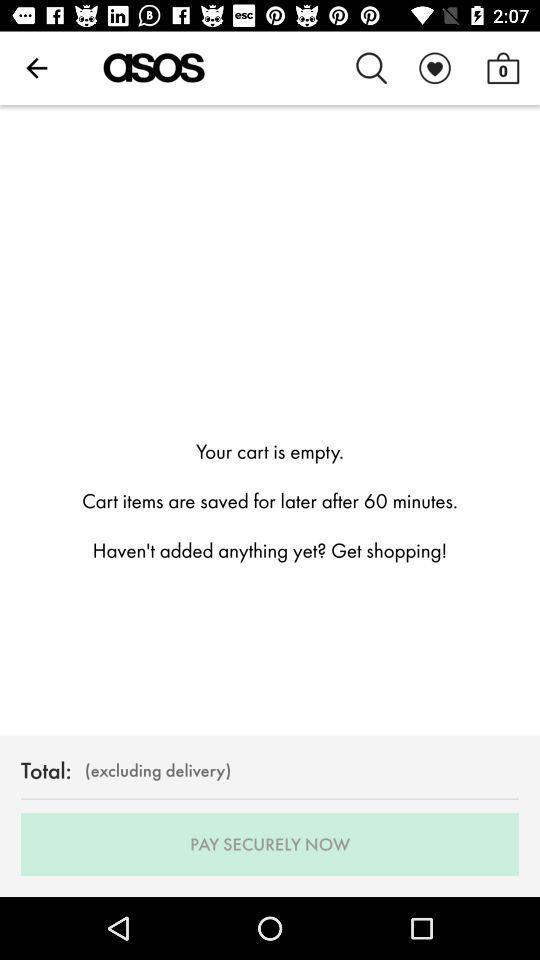How many items are in the cart?
Answer the question using a single word or phrase. 0 